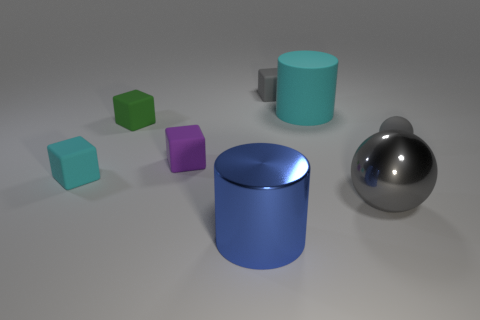Subtract all tiny gray matte blocks. How many blocks are left? 3 Add 1 large yellow things. How many objects exist? 9 Subtract 2 blocks. How many blocks are left? 2 Subtract all cyan cubes. How many cubes are left? 3 Subtract all cylinders. How many objects are left? 6 Subtract all gray cubes. Subtract all brown spheres. How many cubes are left? 3 Add 8 tiny green objects. How many tiny green objects are left? 9 Add 1 big cylinders. How many big cylinders exist? 3 Subtract 0 purple balls. How many objects are left? 8 Subtract all tiny cyan metal cylinders. Subtract all big gray objects. How many objects are left? 7 